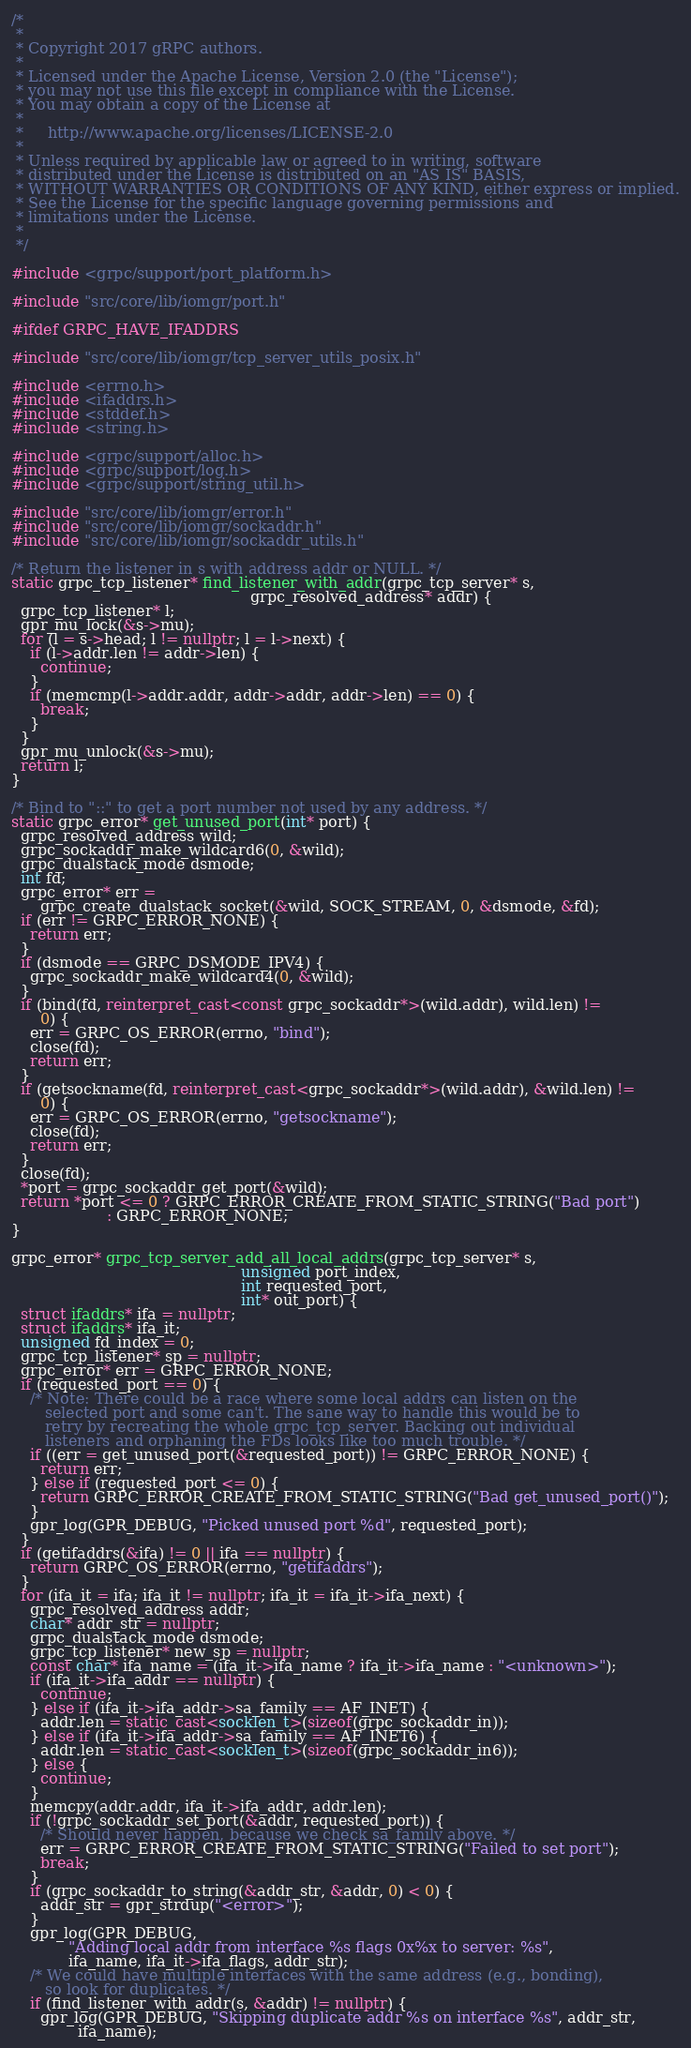<code> <loc_0><loc_0><loc_500><loc_500><_C++_>/*
 *
 * Copyright 2017 gRPC authors.
 *
 * Licensed under the Apache License, Version 2.0 (the "License");
 * you may not use this file except in compliance with the License.
 * You may obtain a copy of the License at
 *
 *     http://www.apache.org/licenses/LICENSE-2.0
 *
 * Unless required by applicable law or agreed to in writing, software
 * distributed under the License is distributed on an "AS IS" BASIS,
 * WITHOUT WARRANTIES OR CONDITIONS OF ANY KIND, either express or implied.
 * See the License for the specific language governing permissions and
 * limitations under the License.
 *
 */

#include <grpc/support/port_platform.h>

#include "src/core/lib/iomgr/port.h"

#ifdef GRPC_HAVE_IFADDRS

#include "src/core/lib/iomgr/tcp_server_utils_posix.h"

#include <errno.h>
#include <ifaddrs.h>
#include <stddef.h>
#include <string.h>

#include <grpc/support/alloc.h>
#include <grpc/support/log.h>
#include <grpc/support/string_util.h>

#include "src/core/lib/iomgr/error.h"
#include "src/core/lib/iomgr/sockaddr.h"
#include "src/core/lib/iomgr/sockaddr_utils.h"

/* Return the listener in s with address addr or NULL. */
static grpc_tcp_listener* find_listener_with_addr(grpc_tcp_server* s,
                                                  grpc_resolved_address* addr) {
  grpc_tcp_listener* l;
  gpr_mu_lock(&s->mu);
  for (l = s->head; l != nullptr; l = l->next) {
    if (l->addr.len != addr->len) {
      continue;
    }
    if (memcmp(l->addr.addr, addr->addr, addr->len) == 0) {
      break;
    }
  }
  gpr_mu_unlock(&s->mu);
  return l;
}

/* Bind to "::" to get a port number not used by any address. */
static grpc_error* get_unused_port(int* port) {
  grpc_resolved_address wild;
  grpc_sockaddr_make_wildcard6(0, &wild);
  grpc_dualstack_mode dsmode;
  int fd;
  grpc_error* err =
      grpc_create_dualstack_socket(&wild, SOCK_STREAM, 0, &dsmode, &fd);
  if (err != GRPC_ERROR_NONE) {
    return err;
  }
  if (dsmode == GRPC_DSMODE_IPV4) {
    grpc_sockaddr_make_wildcard4(0, &wild);
  }
  if (bind(fd, reinterpret_cast<const grpc_sockaddr*>(wild.addr), wild.len) !=
      0) {
    err = GRPC_OS_ERROR(errno, "bind");
    close(fd);
    return err;
  }
  if (getsockname(fd, reinterpret_cast<grpc_sockaddr*>(wild.addr), &wild.len) !=
      0) {
    err = GRPC_OS_ERROR(errno, "getsockname");
    close(fd);
    return err;
  }
  close(fd);
  *port = grpc_sockaddr_get_port(&wild);
  return *port <= 0 ? GRPC_ERROR_CREATE_FROM_STATIC_STRING("Bad port")
                    : GRPC_ERROR_NONE;
}

grpc_error* grpc_tcp_server_add_all_local_addrs(grpc_tcp_server* s,
                                                unsigned port_index,
                                                int requested_port,
                                                int* out_port) {
  struct ifaddrs* ifa = nullptr;
  struct ifaddrs* ifa_it;
  unsigned fd_index = 0;
  grpc_tcp_listener* sp = nullptr;
  grpc_error* err = GRPC_ERROR_NONE;
  if (requested_port == 0) {
    /* Note: There could be a race where some local addrs can listen on the
       selected port and some can't. The sane way to handle this would be to
       retry by recreating the whole grpc_tcp_server. Backing out individual
       listeners and orphaning the FDs looks like too much trouble. */
    if ((err = get_unused_port(&requested_port)) != GRPC_ERROR_NONE) {
      return err;
    } else if (requested_port <= 0) {
      return GRPC_ERROR_CREATE_FROM_STATIC_STRING("Bad get_unused_port()");
    }
    gpr_log(GPR_DEBUG, "Picked unused port %d", requested_port);
  }
  if (getifaddrs(&ifa) != 0 || ifa == nullptr) {
    return GRPC_OS_ERROR(errno, "getifaddrs");
  }
  for (ifa_it = ifa; ifa_it != nullptr; ifa_it = ifa_it->ifa_next) {
    grpc_resolved_address addr;
    char* addr_str = nullptr;
    grpc_dualstack_mode dsmode;
    grpc_tcp_listener* new_sp = nullptr;
    const char* ifa_name = (ifa_it->ifa_name ? ifa_it->ifa_name : "<unknown>");
    if (ifa_it->ifa_addr == nullptr) {
      continue;
    } else if (ifa_it->ifa_addr->sa_family == AF_INET) {
      addr.len = static_cast<socklen_t>(sizeof(grpc_sockaddr_in));
    } else if (ifa_it->ifa_addr->sa_family == AF_INET6) {
      addr.len = static_cast<socklen_t>(sizeof(grpc_sockaddr_in6));
    } else {
      continue;
    }
    memcpy(addr.addr, ifa_it->ifa_addr, addr.len);
    if (!grpc_sockaddr_set_port(&addr, requested_port)) {
      /* Should never happen, because we check sa_family above. */
      err = GRPC_ERROR_CREATE_FROM_STATIC_STRING("Failed to set port");
      break;
    }
    if (grpc_sockaddr_to_string(&addr_str, &addr, 0) < 0) {
      addr_str = gpr_strdup("<error>");
    }
    gpr_log(GPR_DEBUG,
            "Adding local addr from interface %s flags 0x%x to server: %s",
            ifa_name, ifa_it->ifa_flags, addr_str);
    /* We could have multiple interfaces with the same address (e.g., bonding),
       so look for duplicates. */
    if (find_listener_with_addr(s, &addr) != nullptr) {
      gpr_log(GPR_DEBUG, "Skipping duplicate addr %s on interface %s", addr_str,
              ifa_name);</code> 